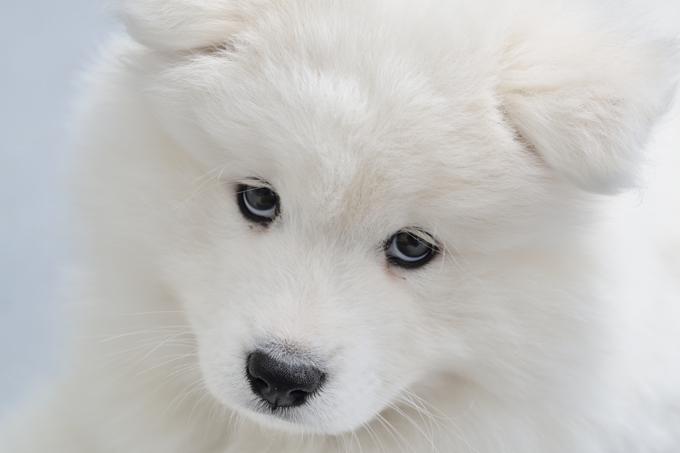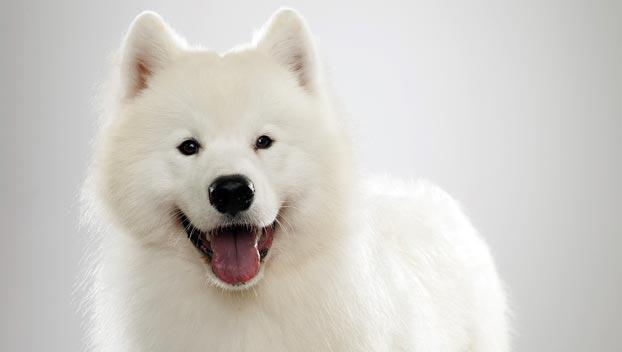The first image is the image on the left, the second image is the image on the right. Examine the images to the left and right. Is the description "Right image features a white dog with its mouth open and tongue showing." accurate? Answer yes or no. Yes. The first image is the image on the left, the second image is the image on the right. Given the left and right images, does the statement "The dog on the right has its mouth wide open." hold true? Answer yes or no. Yes. 